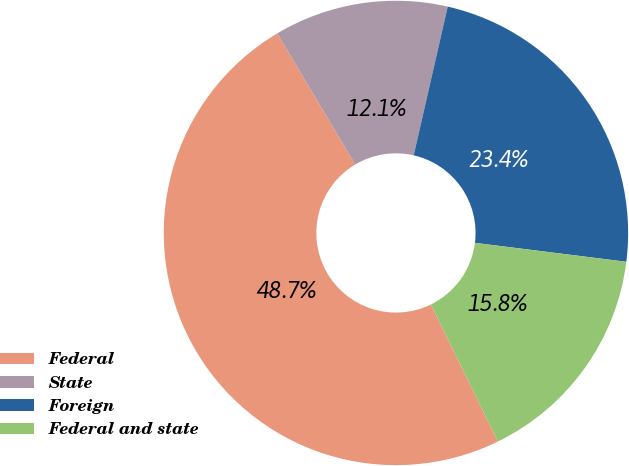<chart> <loc_0><loc_0><loc_500><loc_500><pie_chart><fcel>Federal<fcel>State<fcel>Foreign<fcel>Federal and state<nl><fcel>48.69%<fcel>12.12%<fcel>23.4%<fcel>15.78%<nl></chart> 